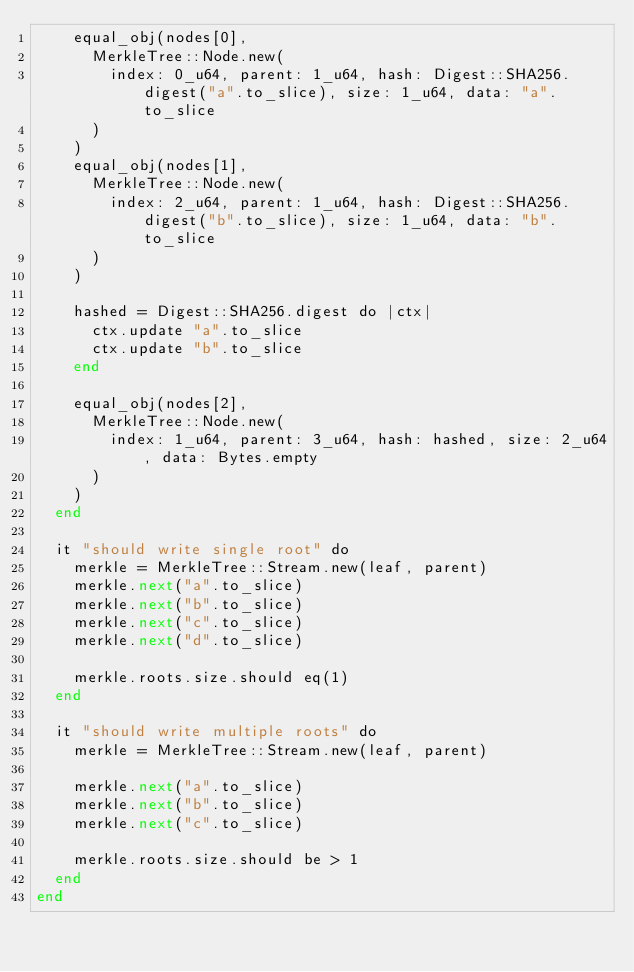Convert code to text. <code><loc_0><loc_0><loc_500><loc_500><_Crystal_>    equal_obj(nodes[0],
      MerkleTree::Node.new(
        index: 0_u64, parent: 1_u64, hash: Digest::SHA256.digest("a".to_slice), size: 1_u64, data: "a".to_slice
      )
    )
    equal_obj(nodes[1],
      MerkleTree::Node.new(
        index: 2_u64, parent: 1_u64, hash: Digest::SHA256.digest("b".to_slice), size: 1_u64, data: "b".to_slice
      )
    )

    hashed = Digest::SHA256.digest do |ctx|
      ctx.update "a".to_slice
      ctx.update "b".to_slice
    end

    equal_obj(nodes[2],
      MerkleTree::Node.new(
        index: 1_u64, parent: 3_u64, hash: hashed, size: 2_u64, data: Bytes.empty
      )
    )
  end

  it "should write single root" do
    merkle = MerkleTree::Stream.new(leaf, parent)
    merkle.next("a".to_slice)
    merkle.next("b".to_slice)
    merkle.next("c".to_slice)
    merkle.next("d".to_slice)

    merkle.roots.size.should eq(1)
  end

  it "should write multiple roots" do
    merkle = MerkleTree::Stream.new(leaf, parent)

    merkle.next("a".to_slice)
    merkle.next("b".to_slice)
    merkle.next("c".to_slice)

    merkle.roots.size.should be > 1
  end
end
</code> 